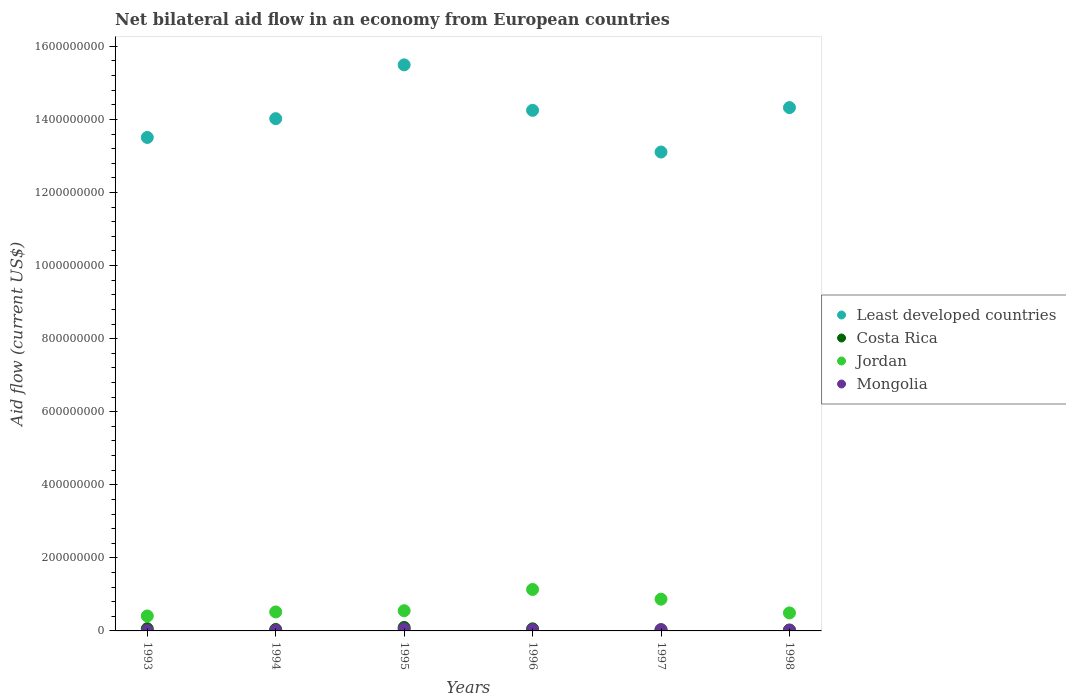How many different coloured dotlines are there?
Give a very brief answer. 4. Is the number of dotlines equal to the number of legend labels?
Give a very brief answer. Yes. What is the net bilateral aid flow in Costa Rica in 1998?
Provide a short and direct response. 2.54e+06. Across all years, what is the maximum net bilateral aid flow in Least developed countries?
Your response must be concise. 1.55e+09. Across all years, what is the minimum net bilateral aid flow in Least developed countries?
Give a very brief answer. 1.31e+09. What is the total net bilateral aid flow in Mongolia in the graph?
Your response must be concise. 1.52e+07. What is the difference between the net bilateral aid flow in Jordan in 1994 and that in 1998?
Provide a short and direct response. 2.73e+06. What is the difference between the net bilateral aid flow in Costa Rica in 1993 and the net bilateral aid flow in Least developed countries in 1994?
Your answer should be very brief. -1.40e+09. What is the average net bilateral aid flow in Mongolia per year?
Your answer should be compact. 2.54e+06. In the year 1994, what is the difference between the net bilateral aid flow in Least developed countries and net bilateral aid flow in Jordan?
Provide a succinct answer. 1.35e+09. What is the ratio of the net bilateral aid flow in Jordan in 1993 to that in 1998?
Ensure brevity in your answer.  0.83. Is the net bilateral aid flow in Jordan in 1993 less than that in 1996?
Your answer should be very brief. Yes. What is the difference between the highest and the second highest net bilateral aid flow in Mongolia?
Make the answer very short. 1.83e+06. What is the difference between the highest and the lowest net bilateral aid flow in Mongolia?
Your answer should be very brief. 4.03e+06. In how many years, is the net bilateral aid flow in Mongolia greater than the average net bilateral aid flow in Mongolia taken over all years?
Your response must be concise. 3. Is it the case that in every year, the sum of the net bilateral aid flow in Jordan and net bilateral aid flow in Mongolia  is greater than the net bilateral aid flow in Least developed countries?
Ensure brevity in your answer.  No. How many dotlines are there?
Provide a short and direct response. 4. How many years are there in the graph?
Your response must be concise. 6. Are the values on the major ticks of Y-axis written in scientific E-notation?
Offer a terse response. No. Does the graph contain grids?
Provide a succinct answer. No. Where does the legend appear in the graph?
Your response must be concise. Center right. What is the title of the graph?
Your response must be concise. Net bilateral aid flow in an economy from European countries. What is the label or title of the X-axis?
Offer a very short reply. Years. What is the label or title of the Y-axis?
Make the answer very short. Aid flow (current US$). What is the Aid flow (current US$) in Least developed countries in 1993?
Your answer should be very brief. 1.35e+09. What is the Aid flow (current US$) of Costa Rica in 1993?
Provide a short and direct response. 6.09e+06. What is the Aid flow (current US$) of Jordan in 1993?
Offer a terse response. 4.09e+07. What is the Aid flow (current US$) in Mongolia in 1993?
Your response must be concise. 9.60e+05. What is the Aid flow (current US$) of Least developed countries in 1994?
Keep it short and to the point. 1.40e+09. What is the Aid flow (current US$) of Costa Rica in 1994?
Offer a very short reply. 4.01e+06. What is the Aid flow (current US$) in Jordan in 1994?
Your answer should be compact. 5.20e+07. What is the Aid flow (current US$) of Mongolia in 1994?
Your answer should be compact. 1.42e+06. What is the Aid flow (current US$) in Least developed countries in 1995?
Offer a very short reply. 1.55e+09. What is the Aid flow (current US$) in Costa Rica in 1995?
Provide a succinct answer. 9.50e+06. What is the Aid flow (current US$) of Jordan in 1995?
Offer a terse response. 5.53e+07. What is the Aid flow (current US$) in Mongolia in 1995?
Keep it short and to the point. 4.99e+06. What is the Aid flow (current US$) in Least developed countries in 1996?
Give a very brief answer. 1.42e+09. What is the Aid flow (current US$) of Costa Rica in 1996?
Your answer should be compact. 5.70e+06. What is the Aid flow (current US$) of Jordan in 1996?
Offer a terse response. 1.13e+08. What is the Aid flow (current US$) in Mongolia in 1996?
Provide a short and direct response. 2.97e+06. What is the Aid flow (current US$) of Least developed countries in 1997?
Make the answer very short. 1.31e+09. What is the Aid flow (current US$) of Costa Rica in 1997?
Provide a short and direct response. 3.22e+06. What is the Aid flow (current US$) in Jordan in 1997?
Offer a very short reply. 8.69e+07. What is the Aid flow (current US$) of Mongolia in 1997?
Make the answer very short. 3.16e+06. What is the Aid flow (current US$) of Least developed countries in 1998?
Provide a succinct answer. 1.43e+09. What is the Aid flow (current US$) of Costa Rica in 1998?
Your answer should be very brief. 2.54e+06. What is the Aid flow (current US$) in Jordan in 1998?
Give a very brief answer. 4.93e+07. What is the Aid flow (current US$) of Mongolia in 1998?
Provide a succinct answer. 1.74e+06. Across all years, what is the maximum Aid flow (current US$) of Least developed countries?
Provide a succinct answer. 1.55e+09. Across all years, what is the maximum Aid flow (current US$) in Costa Rica?
Your response must be concise. 9.50e+06. Across all years, what is the maximum Aid flow (current US$) in Jordan?
Provide a succinct answer. 1.13e+08. Across all years, what is the maximum Aid flow (current US$) of Mongolia?
Your response must be concise. 4.99e+06. Across all years, what is the minimum Aid flow (current US$) in Least developed countries?
Your answer should be compact. 1.31e+09. Across all years, what is the minimum Aid flow (current US$) of Costa Rica?
Provide a short and direct response. 2.54e+06. Across all years, what is the minimum Aid flow (current US$) of Jordan?
Give a very brief answer. 4.09e+07. Across all years, what is the minimum Aid flow (current US$) of Mongolia?
Provide a short and direct response. 9.60e+05. What is the total Aid flow (current US$) of Least developed countries in the graph?
Your answer should be very brief. 8.47e+09. What is the total Aid flow (current US$) in Costa Rica in the graph?
Your response must be concise. 3.11e+07. What is the total Aid flow (current US$) of Jordan in the graph?
Offer a terse response. 3.98e+08. What is the total Aid flow (current US$) of Mongolia in the graph?
Ensure brevity in your answer.  1.52e+07. What is the difference between the Aid flow (current US$) in Least developed countries in 1993 and that in 1994?
Offer a terse response. -5.14e+07. What is the difference between the Aid flow (current US$) of Costa Rica in 1993 and that in 1994?
Give a very brief answer. 2.08e+06. What is the difference between the Aid flow (current US$) in Jordan in 1993 and that in 1994?
Your response must be concise. -1.11e+07. What is the difference between the Aid flow (current US$) in Mongolia in 1993 and that in 1994?
Provide a succinct answer. -4.60e+05. What is the difference between the Aid flow (current US$) of Least developed countries in 1993 and that in 1995?
Ensure brevity in your answer.  -1.99e+08. What is the difference between the Aid flow (current US$) of Costa Rica in 1993 and that in 1995?
Provide a short and direct response. -3.41e+06. What is the difference between the Aid flow (current US$) in Jordan in 1993 and that in 1995?
Your response must be concise. -1.44e+07. What is the difference between the Aid flow (current US$) of Mongolia in 1993 and that in 1995?
Your response must be concise. -4.03e+06. What is the difference between the Aid flow (current US$) in Least developed countries in 1993 and that in 1996?
Give a very brief answer. -7.42e+07. What is the difference between the Aid flow (current US$) of Jordan in 1993 and that in 1996?
Ensure brevity in your answer.  -7.25e+07. What is the difference between the Aid flow (current US$) of Mongolia in 1993 and that in 1996?
Provide a succinct answer. -2.01e+06. What is the difference between the Aid flow (current US$) of Least developed countries in 1993 and that in 1997?
Your answer should be very brief. 3.99e+07. What is the difference between the Aid flow (current US$) in Costa Rica in 1993 and that in 1997?
Provide a short and direct response. 2.87e+06. What is the difference between the Aid flow (current US$) of Jordan in 1993 and that in 1997?
Provide a succinct answer. -4.60e+07. What is the difference between the Aid flow (current US$) in Mongolia in 1993 and that in 1997?
Provide a succinct answer. -2.20e+06. What is the difference between the Aid flow (current US$) in Least developed countries in 1993 and that in 1998?
Ensure brevity in your answer.  -8.18e+07. What is the difference between the Aid flow (current US$) of Costa Rica in 1993 and that in 1998?
Your response must be concise. 3.55e+06. What is the difference between the Aid flow (current US$) in Jordan in 1993 and that in 1998?
Make the answer very short. -8.36e+06. What is the difference between the Aid flow (current US$) of Mongolia in 1993 and that in 1998?
Provide a short and direct response. -7.80e+05. What is the difference between the Aid flow (current US$) of Least developed countries in 1994 and that in 1995?
Offer a very short reply. -1.47e+08. What is the difference between the Aid flow (current US$) in Costa Rica in 1994 and that in 1995?
Provide a succinct answer. -5.49e+06. What is the difference between the Aid flow (current US$) of Jordan in 1994 and that in 1995?
Your answer should be very brief. -3.35e+06. What is the difference between the Aid flow (current US$) of Mongolia in 1994 and that in 1995?
Provide a short and direct response. -3.57e+06. What is the difference between the Aid flow (current US$) of Least developed countries in 1994 and that in 1996?
Offer a very short reply. -2.28e+07. What is the difference between the Aid flow (current US$) in Costa Rica in 1994 and that in 1996?
Your response must be concise. -1.69e+06. What is the difference between the Aid flow (current US$) of Jordan in 1994 and that in 1996?
Your answer should be very brief. -6.14e+07. What is the difference between the Aid flow (current US$) in Mongolia in 1994 and that in 1996?
Provide a short and direct response. -1.55e+06. What is the difference between the Aid flow (current US$) in Least developed countries in 1994 and that in 1997?
Your answer should be compact. 9.13e+07. What is the difference between the Aid flow (current US$) in Costa Rica in 1994 and that in 1997?
Your response must be concise. 7.90e+05. What is the difference between the Aid flow (current US$) of Jordan in 1994 and that in 1997?
Make the answer very short. -3.50e+07. What is the difference between the Aid flow (current US$) in Mongolia in 1994 and that in 1997?
Provide a succinct answer. -1.74e+06. What is the difference between the Aid flow (current US$) in Least developed countries in 1994 and that in 1998?
Your answer should be compact. -3.03e+07. What is the difference between the Aid flow (current US$) of Costa Rica in 1994 and that in 1998?
Provide a short and direct response. 1.47e+06. What is the difference between the Aid flow (current US$) in Jordan in 1994 and that in 1998?
Ensure brevity in your answer.  2.73e+06. What is the difference between the Aid flow (current US$) of Mongolia in 1994 and that in 1998?
Make the answer very short. -3.20e+05. What is the difference between the Aid flow (current US$) in Least developed countries in 1995 and that in 1996?
Your answer should be very brief. 1.24e+08. What is the difference between the Aid flow (current US$) of Costa Rica in 1995 and that in 1996?
Offer a terse response. 3.80e+06. What is the difference between the Aid flow (current US$) of Jordan in 1995 and that in 1996?
Ensure brevity in your answer.  -5.81e+07. What is the difference between the Aid flow (current US$) in Mongolia in 1995 and that in 1996?
Offer a very short reply. 2.02e+06. What is the difference between the Aid flow (current US$) of Least developed countries in 1995 and that in 1997?
Keep it short and to the point. 2.39e+08. What is the difference between the Aid flow (current US$) of Costa Rica in 1995 and that in 1997?
Ensure brevity in your answer.  6.28e+06. What is the difference between the Aid flow (current US$) of Jordan in 1995 and that in 1997?
Keep it short and to the point. -3.16e+07. What is the difference between the Aid flow (current US$) in Mongolia in 1995 and that in 1997?
Ensure brevity in your answer.  1.83e+06. What is the difference between the Aid flow (current US$) in Least developed countries in 1995 and that in 1998?
Your answer should be compact. 1.17e+08. What is the difference between the Aid flow (current US$) of Costa Rica in 1995 and that in 1998?
Provide a short and direct response. 6.96e+06. What is the difference between the Aid flow (current US$) of Jordan in 1995 and that in 1998?
Make the answer very short. 6.08e+06. What is the difference between the Aid flow (current US$) of Mongolia in 1995 and that in 1998?
Your response must be concise. 3.25e+06. What is the difference between the Aid flow (current US$) in Least developed countries in 1996 and that in 1997?
Your response must be concise. 1.14e+08. What is the difference between the Aid flow (current US$) of Costa Rica in 1996 and that in 1997?
Offer a very short reply. 2.48e+06. What is the difference between the Aid flow (current US$) in Jordan in 1996 and that in 1997?
Make the answer very short. 2.65e+07. What is the difference between the Aid flow (current US$) in Least developed countries in 1996 and that in 1998?
Give a very brief answer. -7.51e+06. What is the difference between the Aid flow (current US$) in Costa Rica in 1996 and that in 1998?
Offer a terse response. 3.16e+06. What is the difference between the Aid flow (current US$) in Jordan in 1996 and that in 1998?
Offer a terse response. 6.42e+07. What is the difference between the Aid flow (current US$) of Mongolia in 1996 and that in 1998?
Provide a succinct answer. 1.23e+06. What is the difference between the Aid flow (current US$) of Least developed countries in 1997 and that in 1998?
Ensure brevity in your answer.  -1.22e+08. What is the difference between the Aid flow (current US$) in Costa Rica in 1997 and that in 1998?
Make the answer very short. 6.80e+05. What is the difference between the Aid flow (current US$) of Jordan in 1997 and that in 1998?
Provide a short and direct response. 3.77e+07. What is the difference between the Aid flow (current US$) in Mongolia in 1997 and that in 1998?
Provide a succinct answer. 1.42e+06. What is the difference between the Aid flow (current US$) of Least developed countries in 1993 and the Aid flow (current US$) of Costa Rica in 1994?
Make the answer very short. 1.35e+09. What is the difference between the Aid flow (current US$) in Least developed countries in 1993 and the Aid flow (current US$) in Jordan in 1994?
Ensure brevity in your answer.  1.30e+09. What is the difference between the Aid flow (current US$) of Least developed countries in 1993 and the Aid flow (current US$) of Mongolia in 1994?
Provide a succinct answer. 1.35e+09. What is the difference between the Aid flow (current US$) of Costa Rica in 1993 and the Aid flow (current US$) of Jordan in 1994?
Your answer should be very brief. -4.59e+07. What is the difference between the Aid flow (current US$) of Costa Rica in 1993 and the Aid flow (current US$) of Mongolia in 1994?
Offer a very short reply. 4.67e+06. What is the difference between the Aid flow (current US$) of Jordan in 1993 and the Aid flow (current US$) of Mongolia in 1994?
Ensure brevity in your answer.  3.95e+07. What is the difference between the Aid flow (current US$) of Least developed countries in 1993 and the Aid flow (current US$) of Costa Rica in 1995?
Provide a succinct answer. 1.34e+09. What is the difference between the Aid flow (current US$) in Least developed countries in 1993 and the Aid flow (current US$) in Jordan in 1995?
Your response must be concise. 1.30e+09. What is the difference between the Aid flow (current US$) of Least developed countries in 1993 and the Aid flow (current US$) of Mongolia in 1995?
Your response must be concise. 1.35e+09. What is the difference between the Aid flow (current US$) in Costa Rica in 1993 and the Aid flow (current US$) in Jordan in 1995?
Offer a very short reply. -4.92e+07. What is the difference between the Aid flow (current US$) in Costa Rica in 1993 and the Aid flow (current US$) in Mongolia in 1995?
Provide a short and direct response. 1.10e+06. What is the difference between the Aid flow (current US$) of Jordan in 1993 and the Aid flow (current US$) of Mongolia in 1995?
Keep it short and to the point. 3.59e+07. What is the difference between the Aid flow (current US$) in Least developed countries in 1993 and the Aid flow (current US$) in Costa Rica in 1996?
Make the answer very short. 1.34e+09. What is the difference between the Aid flow (current US$) in Least developed countries in 1993 and the Aid flow (current US$) in Jordan in 1996?
Provide a succinct answer. 1.24e+09. What is the difference between the Aid flow (current US$) of Least developed countries in 1993 and the Aid flow (current US$) of Mongolia in 1996?
Keep it short and to the point. 1.35e+09. What is the difference between the Aid flow (current US$) of Costa Rica in 1993 and the Aid flow (current US$) of Jordan in 1996?
Your response must be concise. -1.07e+08. What is the difference between the Aid flow (current US$) of Costa Rica in 1993 and the Aid flow (current US$) of Mongolia in 1996?
Keep it short and to the point. 3.12e+06. What is the difference between the Aid flow (current US$) in Jordan in 1993 and the Aid flow (current US$) in Mongolia in 1996?
Ensure brevity in your answer.  3.79e+07. What is the difference between the Aid flow (current US$) in Least developed countries in 1993 and the Aid flow (current US$) in Costa Rica in 1997?
Your response must be concise. 1.35e+09. What is the difference between the Aid flow (current US$) in Least developed countries in 1993 and the Aid flow (current US$) in Jordan in 1997?
Your answer should be very brief. 1.26e+09. What is the difference between the Aid flow (current US$) of Least developed countries in 1993 and the Aid flow (current US$) of Mongolia in 1997?
Make the answer very short. 1.35e+09. What is the difference between the Aid flow (current US$) of Costa Rica in 1993 and the Aid flow (current US$) of Jordan in 1997?
Your response must be concise. -8.08e+07. What is the difference between the Aid flow (current US$) in Costa Rica in 1993 and the Aid flow (current US$) in Mongolia in 1997?
Offer a very short reply. 2.93e+06. What is the difference between the Aid flow (current US$) of Jordan in 1993 and the Aid flow (current US$) of Mongolia in 1997?
Make the answer very short. 3.77e+07. What is the difference between the Aid flow (current US$) of Least developed countries in 1993 and the Aid flow (current US$) of Costa Rica in 1998?
Offer a very short reply. 1.35e+09. What is the difference between the Aid flow (current US$) in Least developed countries in 1993 and the Aid flow (current US$) in Jordan in 1998?
Provide a short and direct response. 1.30e+09. What is the difference between the Aid flow (current US$) of Least developed countries in 1993 and the Aid flow (current US$) of Mongolia in 1998?
Provide a short and direct response. 1.35e+09. What is the difference between the Aid flow (current US$) in Costa Rica in 1993 and the Aid flow (current US$) in Jordan in 1998?
Provide a short and direct response. -4.32e+07. What is the difference between the Aid flow (current US$) in Costa Rica in 1993 and the Aid flow (current US$) in Mongolia in 1998?
Ensure brevity in your answer.  4.35e+06. What is the difference between the Aid flow (current US$) in Jordan in 1993 and the Aid flow (current US$) in Mongolia in 1998?
Offer a terse response. 3.92e+07. What is the difference between the Aid flow (current US$) of Least developed countries in 1994 and the Aid flow (current US$) of Costa Rica in 1995?
Make the answer very short. 1.39e+09. What is the difference between the Aid flow (current US$) in Least developed countries in 1994 and the Aid flow (current US$) in Jordan in 1995?
Your answer should be compact. 1.35e+09. What is the difference between the Aid flow (current US$) of Least developed countries in 1994 and the Aid flow (current US$) of Mongolia in 1995?
Your answer should be very brief. 1.40e+09. What is the difference between the Aid flow (current US$) of Costa Rica in 1994 and the Aid flow (current US$) of Jordan in 1995?
Provide a short and direct response. -5.13e+07. What is the difference between the Aid flow (current US$) in Costa Rica in 1994 and the Aid flow (current US$) in Mongolia in 1995?
Offer a terse response. -9.80e+05. What is the difference between the Aid flow (current US$) of Jordan in 1994 and the Aid flow (current US$) of Mongolia in 1995?
Offer a terse response. 4.70e+07. What is the difference between the Aid flow (current US$) of Least developed countries in 1994 and the Aid flow (current US$) of Costa Rica in 1996?
Ensure brevity in your answer.  1.40e+09. What is the difference between the Aid flow (current US$) in Least developed countries in 1994 and the Aid flow (current US$) in Jordan in 1996?
Ensure brevity in your answer.  1.29e+09. What is the difference between the Aid flow (current US$) of Least developed countries in 1994 and the Aid flow (current US$) of Mongolia in 1996?
Provide a succinct answer. 1.40e+09. What is the difference between the Aid flow (current US$) in Costa Rica in 1994 and the Aid flow (current US$) in Jordan in 1996?
Your answer should be very brief. -1.09e+08. What is the difference between the Aid flow (current US$) of Costa Rica in 1994 and the Aid flow (current US$) of Mongolia in 1996?
Offer a very short reply. 1.04e+06. What is the difference between the Aid flow (current US$) in Jordan in 1994 and the Aid flow (current US$) in Mongolia in 1996?
Provide a short and direct response. 4.90e+07. What is the difference between the Aid flow (current US$) of Least developed countries in 1994 and the Aid flow (current US$) of Costa Rica in 1997?
Your response must be concise. 1.40e+09. What is the difference between the Aid flow (current US$) in Least developed countries in 1994 and the Aid flow (current US$) in Jordan in 1997?
Ensure brevity in your answer.  1.32e+09. What is the difference between the Aid flow (current US$) in Least developed countries in 1994 and the Aid flow (current US$) in Mongolia in 1997?
Provide a short and direct response. 1.40e+09. What is the difference between the Aid flow (current US$) of Costa Rica in 1994 and the Aid flow (current US$) of Jordan in 1997?
Your answer should be very brief. -8.29e+07. What is the difference between the Aid flow (current US$) of Costa Rica in 1994 and the Aid flow (current US$) of Mongolia in 1997?
Ensure brevity in your answer.  8.50e+05. What is the difference between the Aid flow (current US$) in Jordan in 1994 and the Aid flow (current US$) in Mongolia in 1997?
Provide a short and direct response. 4.88e+07. What is the difference between the Aid flow (current US$) of Least developed countries in 1994 and the Aid flow (current US$) of Costa Rica in 1998?
Your answer should be compact. 1.40e+09. What is the difference between the Aid flow (current US$) in Least developed countries in 1994 and the Aid flow (current US$) in Jordan in 1998?
Provide a succinct answer. 1.35e+09. What is the difference between the Aid flow (current US$) of Least developed countries in 1994 and the Aid flow (current US$) of Mongolia in 1998?
Ensure brevity in your answer.  1.40e+09. What is the difference between the Aid flow (current US$) of Costa Rica in 1994 and the Aid flow (current US$) of Jordan in 1998?
Provide a succinct answer. -4.52e+07. What is the difference between the Aid flow (current US$) in Costa Rica in 1994 and the Aid flow (current US$) in Mongolia in 1998?
Ensure brevity in your answer.  2.27e+06. What is the difference between the Aid flow (current US$) of Jordan in 1994 and the Aid flow (current US$) of Mongolia in 1998?
Give a very brief answer. 5.02e+07. What is the difference between the Aid flow (current US$) of Least developed countries in 1995 and the Aid flow (current US$) of Costa Rica in 1996?
Provide a succinct answer. 1.54e+09. What is the difference between the Aid flow (current US$) in Least developed countries in 1995 and the Aid flow (current US$) in Jordan in 1996?
Provide a short and direct response. 1.44e+09. What is the difference between the Aid flow (current US$) in Least developed countries in 1995 and the Aid flow (current US$) in Mongolia in 1996?
Offer a very short reply. 1.55e+09. What is the difference between the Aid flow (current US$) in Costa Rica in 1995 and the Aid flow (current US$) in Jordan in 1996?
Offer a very short reply. -1.04e+08. What is the difference between the Aid flow (current US$) in Costa Rica in 1995 and the Aid flow (current US$) in Mongolia in 1996?
Provide a succinct answer. 6.53e+06. What is the difference between the Aid flow (current US$) in Jordan in 1995 and the Aid flow (current US$) in Mongolia in 1996?
Offer a very short reply. 5.24e+07. What is the difference between the Aid flow (current US$) of Least developed countries in 1995 and the Aid flow (current US$) of Costa Rica in 1997?
Offer a terse response. 1.55e+09. What is the difference between the Aid flow (current US$) in Least developed countries in 1995 and the Aid flow (current US$) in Jordan in 1997?
Your answer should be compact. 1.46e+09. What is the difference between the Aid flow (current US$) of Least developed countries in 1995 and the Aid flow (current US$) of Mongolia in 1997?
Keep it short and to the point. 1.55e+09. What is the difference between the Aid flow (current US$) of Costa Rica in 1995 and the Aid flow (current US$) of Jordan in 1997?
Keep it short and to the point. -7.74e+07. What is the difference between the Aid flow (current US$) in Costa Rica in 1995 and the Aid flow (current US$) in Mongolia in 1997?
Your answer should be very brief. 6.34e+06. What is the difference between the Aid flow (current US$) of Jordan in 1995 and the Aid flow (current US$) of Mongolia in 1997?
Your answer should be very brief. 5.22e+07. What is the difference between the Aid flow (current US$) in Least developed countries in 1995 and the Aid flow (current US$) in Costa Rica in 1998?
Offer a very short reply. 1.55e+09. What is the difference between the Aid flow (current US$) in Least developed countries in 1995 and the Aid flow (current US$) in Jordan in 1998?
Provide a succinct answer. 1.50e+09. What is the difference between the Aid flow (current US$) in Least developed countries in 1995 and the Aid flow (current US$) in Mongolia in 1998?
Offer a terse response. 1.55e+09. What is the difference between the Aid flow (current US$) in Costa Rica in 1995 and the Aid flow (current US$) in Jordan in 1998?
Keep it short and to the point. -3.98e+07. What is the difference between the Aid flow (current US$) in Costa Rica in 1995 and the Aid flow (current US$) in Mongolia in 1998?
Your response must be concise. 7.76e+06. What is the difference between the Aid flow (current US$) in Jordan in 1995 and the Aid flow (current US$) in Mongolia in 1998?
Your response must be concise. 5.36e+07. What is the difference between the Aid flow (current US$) in Least developed countries in 1996 and the Aid flow (current US$) in Costa Rica in 1997?
Offer a very short reply. 1.42e+09. What is the difference between the Aid flow (current US$) in Least developed countries in 1996 and the Aid flow (current US$) in Jordan in 1997?
Ensure brevity in your answer.  1.34e+09. What is the difference between the Aid flow (current US$) of Least developed countries in 1996 and the Aid flow (current US$) of Mongolia in 1997?
Ensure brevity in your answer.  1.42e+09. What is the difference between the Aid flow (current US$) of Costa Rica in 1996 and the Aid flow (current US$) of Jordan in 1997?
Offer a terse response. -8.12e+07. What is the difference between the Aid flow (current US$) of Costa Rica in 1996 and the Aid flow (current US$) of Mongolia in 1997?
Your answer should be very brief. 2.54e+06. What is the difference between the Aid flow (current US$) in Jordan in 1996 and the Aid flow (current US$) in Mongolia in 1997?
Your answer should be compact. 1.10e+08. What is the difference between the Aid flow (current US$) in Least developed countries in 1996 and the Aid flow (current US$) in Costa Rica in 1998?
Offer a very short reply. 1.42e+09. What is the difference between the Aid flow (current US$) in Least developed countries in 1996 and the Aid flow (current US$) in Jordan in 1998?
Offer a very short reply. 1.38e+09. What is the difference between the Aid flow (current US$) in Least developed countries in 1996 and the Aid flow (current US$) in Mongolia in 1998?
Provide a succinct answer. 1.42e+09. What is the difference between the Aid flow (current US$) of Costa Rica in 1996 and the Aid flow (current US$) of Jordan in 1998?
Provide a short and direct response. -4.36e+07. What is the difference between the Aid flow (current US$) in Costa Rica in 1996 and the Aid flow (current US$) in Mongolia in 1998?
Offer a very short reply. 3.96e+06. What is the difference between the Aid flow (current US$) in Jordan in 1996 and the Aid flow (current US$) in Mongolia in 1998?
Your response must be concise. 1.12e+08. What is the difference between the Aid flow (current US$) of Least developed countries in 1997 and the Aid flow (current US$) of Costa Rica in 1998?
Your answer should be compact. 1.31e+09. What is the difference between the Aid flow (current US$) in Least developed countries in 1997 and the Aid flow (current US$) in Jordan in 1998?
Offer a very short reply. 1.26e+09. What is the difference between the Aid flow (current US$) in Least developed countries in 1997 and the Aid flow (current US$) in Mongolia in 1998?
Make the answer very short. 1.31e+09. What is the difference between the Aid flow (current US$) in Costa Rica in 1997 and the Aid flow (current US$) in Jordan in 1998?
Your answer should be very brief. -4.60e+07. What is the difference between the Aid flow (current US$) of Costa Rica in 1997 and the Aid flow (current US$) of Mongolia in 1998?
Offer a very short reply. 1.48e+06. What is the difference between the Aid flow (current US$) in Jordan in 1997 and the Aid flow (current US$) in Mongolia in 1998?
Offer a very short reply. 8.52e+07. What is the average Aid flow (current US$) of Least developed countries per year?
Your response must be concise. 1.41e+09. What is the average Aid flow (current US$) in Costa Rica per year?
Offer a very short reply. 5.18e+06. What is the average Aid flow (current US$) of Jordan per year?
Your answer should be compact. 6.63e+07. What is the average Aid flow (current US$) in Mongolia per year?
Give a very brief answer. 2.54e+06. In the year 1993, what is the difference between the Aid flow (current US$) in Least developed countries and Aid flow (current US$) in Costa Rica?
Provide a short and direct response. 1.34e+09. In the year 1993, what is the difference between the Aid flow (current US$) of Least developed countries and Aid flow (current US$) of Jordan?
Your answer should be very brief. 1.31e+09. In the year 1993, what is the difference between the Aid flow (current US$) in Least developed countries and Aid flow (current US$) in Mongolia?
Your answer should be very brief. 1.35e+09. In the year 1993, what is the difference between the Aid flow (current US$) of Costa Rica and Aid flow (current US$) of Jordan?
Your response must be concise. -3.48e+07. In the year 1993, what is the difference between the Aid flow (current US$) of Costa Rica and Aid flow (current US$) of Mongolia?
Offer a terse response. 5.13e+06. In the year 1993, what is the difference between the Aid flow (current US$) of Jordan and Aid flow (current US$) of Mongolia?
Give a very brief answer. 3.99e+07. In the year 1994, what is the difference between the Aid flow (current US$) of Least developed countries and Aid flow (current US$) of Costa Rica?
Make the answer very short. 1.40e+09. In the year 1994, what is the difference between the Aid flow (current US$) in Least developed countries and Aid flow (current US$) in Jordan?
Your response must be concise. 1.35e+09. In the year 1994, what is the difference between the Aid flow (current US$) in Least developed countries and Aid flow (current US$) in Mongolia?
Provide a short and direct response. 1.40e+09. In the year 1994, what is the difference between the Aid flow (current US$) in Costa Rica and Aid flow (current US$) in Jordan?
Your answer should be very brief. -4.80e+07. In the year 1994, what is the difference between the Aid flow (current US$) in Costa Rica and Aid flow (current US$) in Mongolia?
Make the answer very short. 2.59e+06. In the year 1994, what is the difference between the Aid flow (current US$) in Jordan and Aid flow (current US$) in Mongolia?
Ensure brevity in your answer.  5.06e+07. In the year 1995, what is the difference between the Aid flow (current US$) in Least developed countries and Aid flow (current US$) in Costa Rica?
Provide a succinct answer. 1.54e+09. In the year 1995, what is the difference between the Aid flow (current US$) in Least developed countries and Aid flow (current US$) in Jordan?
Ensure brevity in your answer.  1.49e+09. In the year 1995, what is the difference between the Aid flow (current US$) of Least developed countries and Aid flow (current US$) of Mongolia?
Keep it short and to the point. 1.54e+09. In the year 1995, what is the difference between the Aid flow (current US$) of Costa Rica and Aid flow (current US$) of Jordan?
Ensure brevity in your answer.  -4.58e+07. In the year 1995, what is the difference between the Aid flow (current US$) of Costa Rica and Aid flow (current US$) of Mongolia?
Give a very brief answer. 4.51e+06. In the year 1995, what is the difference between the Aid flow (current US$) in Jordan and Aid flow (current US$) in Mongolia?
Provide a succinct answer. 5.04e+07. In the year 1996, what is the difference between the Aid flow (current US$) of Least developed countries and Aid flow (current US$) of Costa Rica?
Keep it short and to the point. 1.42e+09. In the year 1996, what is the difference between the Aid flow (current US$) in Least developed countries and Aid flow (current US$) in Jordan?
Your response must be concise. 1.31e+09. In the year 1996, what is the difference between the Aid flow (current US$) in Least developed countries and Aid flow (current US$) in Mongolia?
Offer a terse response. 1.42e+09. In the year 1996, what is the difference between the Aid flow (current US$) in Costa Rica and Aid flow (current US$) in Jordan?
Your response must be concise. -1.08e+08. In the year 1996, what is the difference between the Aid flow (current US$) in Costa Rica and Aid flow (current US$) in Mongolia?
Give a very brief answer. 2.73e+06. In the year 1996, what is the difference between the Aid flow (current US$) in Jordan and Aid flow (current US$) in Mongolia?
Your answer should be very brief. 1.10e+08. In the year 1997, what is the difference between the Aid flow (current US$) of Least developed countries and Aid flow (current US$) of Costa Rica?
Provide a short and direct response. 1.31e+09. In the year 1997, what is the difference between the Aid flow (current US$) in Least developed countries and Aid flow (current US$) in Jordan?
Offer a very short reply. 1.22e+09. In the year 1997, what is the difference between the Aid flow (current US$) in Least developed countries and Aid flow (current US$) in Mongolia?
Your answer should be very brief. 1.31e+09. In the year 1997, what is the difference between the Aid flow (current US$) in Costa Rica and Aid flow (current US$) in Jordan?
Offer a very short reply. -8.37e+07. In the year 1997, what is the difference between the Aid flow (current US$) of Jordan and Aid flow (current US$) of Mongolia?
Offer a terse response. 8.38e+07. In the year 1998, what is the difference between the Aid flow (current US$) in Least developed countries and Aid flow (current US$) in Costa Rica?
Provide a short and direct response. 1.43e+09. In the year 1998, what is the difference between the Aid flow (current US$) of Least developed countries and Aid flow (current US$) of Jordan?
Your answer should be very brief. 1.38e+09. In the year 1998, what is the difference between the Aid flow (current US$) of Least developed countries and Aid flow (current US$) of Mongolia?
Provide a short and direct response. 1.43e+09. In the year 1998, what is the difference between the Aid flow (current US$) in Costa Rica and Aid flow (current US$) in Jordan?
Ensure brevity in your answer.  -4.67e+07. In the year 1998, what is the difference between the Aid flow (current US$) in Jordan and Aid flow (current US$) in Mongolia?
Your answer should be very brief. 4.75e+07. What is the ratio of the Aid flow (current US$) in Least developed countries in 1993 to that in 1994?
Your answer should be compact. 0.96. What is the ratio of the Aid flow (current US$) of Costa Rica in 1993 to that in 1994?
Provide a short and direct response. 1.52. What is the ratio of the Aid flow (current US$) of Jordan in 1993 to that in 1994?
Provide a short and direct response. 0.79. What is the ratio of the Aid flow (current US$) of Mongolia in 1993 to that in 1994?
Your answer should be compact. 0.68. What is the ratio of the Aid flow (current US$) in Least developed countries in 1993 to that in 1995?
Ensure brevity in your answer.  0.87. What is the ratio of the Aid flow (current US$) of Costa Rica in 1993 to that in 1995?
Your response must be concise. 0.64. What is the ratio of the Aid flow (current US$) of Jordan in 1993 to that in 1995?
Keep it short and to the point. 0.74. What is the ratio of the Aid flow (current US$) in Mongolia in 1993 to that in 1995?
Offer a terse response. 0.19. What is the ratio of the Aid flow (current US$) of Least developed countries in 1993 to that in 1996?
Offer a very short reply. 0.95. What is the ratio of the Aid flow (current US$) in Costa Rica in 1993 to that in 1996?
Your answer should be compact. 1.07. What is the ratio of the Aid flow (current US$) of Jordan in 1993 to that in 1996?
Provide a succinct answer. 0.36. What is the ratio of the Aid flow (current US$) in Mongolia in 1993 to that in 1996?
Make the answer very short. 0.32. What is the ratio of the Aid flow (current US$) of Least developed countries in 1993 to that in 1997?
Provide a succinct answer. 1.03. What is the ratio of the Aid flow (current US$) in Costa Rica in 1993 to that in 1997?
Give a very brief answer. 1.89. What is the ratio of the Aid flow (current US$) of Jordan in 1993 to that in 1997?
Your answer should be very brief. 0.47. What is the ratio of the Aid flow (current US$) of Mongolia in 1993 to that in 1997?
Keep it short and to the point. 0.3. What is the ratio of the Aid flow (current US$) of Least developed countries in 1993 to that in 1998?
Ensure brevity in your answer.  0.94. What is the ratio of the Aid flow (current US$) of Costa Rica in 1993 to that in 1998?
Your answer should be compact. 2.4. What is the ratio of the Aid flow (current US$) of Jordan in 1993 to that in 1998?
Ensure brevity in your answer.  0.83. What is the ratio of the Aid flow (current US$) of Mongolia in 1993 to that in 1998?
Keep it short and to the point. 0.55. What is the ratio of the Aid flow (current US$) of Least developed countries in 1994 to that in 1995?
Provide a succinct answer. 0.91. What is the ratio of the Aid flow (current US$) in Costa Rica in 1994 to that in 1995?
Make the answer very short. 0.42. What is the ratio of the Aid flow (current US$) of Jordan in 1994 to that in 1995?
Ensure brevity in your answer.  0.94. What is the ratio of the Aid flow (current US$) of Mongolia in 1994 to that in 1995?
Offer a very short reply. 0.28. What is the ratio of the Aid flow (current US$) in Costa Rica in 1994 to that in 1996?
Provide a short and direct response. 0.7. What is the ratio of the Aid flow (current US$) of Jordan in 1994 to that in 1996?
Your response must be concise. 0.46. What is the ratio of the Aid flow (current US$) in Mongolia in 1994 to that in 1996?
Provide a short and direct response. 0.48. What is the ratio of the Aid flow (current US$) in Least developed countries in 1994 to that in 1997?
Provide a succinct answer. 1.07. What is the ratio of the Aid flow (current US$) of Costa Rica in 1994 to that in 1997?
Ensure brevity in your answer.  1.25. What is the ratio of the Aid flow (current US$) of Jordan in 1994 to that in 1997?
Offer a terse response. 0.6. What is the ratio of the Aid flow (current US$) in Mongolia in 1994 to that in 1997?
Offer a terse response. 0.45. What is the ratio of the Aid flow (current US$) of Least developed countries in 1994 to that in 1998?
Your answer should be compact. 0.98. What is the ratio of the Aid flow (current US$) of Costa Rica in 1994 to that in 1998?
Provide a succinct answer. 1.58. What is the ratio of the Aid flow (current US$) in Jordan in 1994 to that in 1998?
Your answer should be compact. 1.06. What is the ratio of the Aid flow (current US$) in Mongolia in 1994 to that in 1998?
Your answer should be very brief. 0.82. What is the ratio of the Aid flow (current US$) of Least developed countries in 1995 to that in 1996?
Ensure brevity in your answer.  1.09. What is the ratio of the Aid flow (current US$) in Costa Rica in 1995 to that in 1996?
Offer a terse response. 1.67. What is the ratio of the Aid flow (current US$) in Jordan in 1995 to that in 1996?
Provide a short and direct response. 0.49. What is the ratio of the Aid flow (current US$) in Mongolia in 1995 to that in 1996?
Keep it short and to the point. 1.68. What is the ratio of the Aid flow (current US$) in Least developed countries in 1995 to that in 1997?
Make the answer very short. 1.18. What is the ratio of the Aid flow (current US$) of Costa Rica in 1995 to that in 1997?
Offer a very short reply. 2.95. What is the ratio of the Aid flow (current US$) in Jordan in 1995 to that in 1997?
Offer a very short reply. 0.64. What is the ratio of the Aid flow (current US$) of Mongolia in 1995 to that in 1997?
Your response must be concise. 1.58. What is the ratio of the Aid flow (current US$) in Least developed countries in 1995 to that in 1998?
Provide a short and direct response. 1.08. What is the ratio of the Aid flow (current US$) of Costa Rica in 1995 to that in 1998?
Make the answer very short. 3.74. What is the ratio of the Aid flow (current US$) in Jordan in 1995 to that in 1998?
Your response must be concise. 1.12. What is the ratio of the Aid flow (current US$) of Mongolia in 1995 to that in 1998?
Make the answer very short. 2.87. What is the ratio of the Aid flow (current US$) of Least developed countries in 1996 to that in 1997?
Keep it short and to the point. 1.09. What is the ratio of the Aid flow (current US$) in Costa Rica in 1996 to that in 1997?
Keep it short and to the point. 1.77. What is the ratio of the Aid flow (current US$) in Jordan in 1996 to that in 1997?
Your answer should be very brief. 1.3. What is the ratio of the Aid flow (current US$) of Mongolia in 1996 to that in 1997?
Give a very brief answer. 0.94. What is the ratio of the Aid flow (current US$) in Costa Rica in 1996 to that in 1998?
Provide a short and direct response. 2.24. What is the ratio of the Aid flow (current US$) of Jordan in 1996 to that in 1998?
Provide a short and direct response. 2.3. What is the ratio of the Aid flow (current US$) in Mongolia in 1996 to that in 1998?
Offer a very short reply. 1.71. What is the ratio of the Aid flow (current US$) of Least developed countries in 1997 to that in 1998?
Provide a short and direct response. 0.92. What is the ratio of the Aid flow (current US$) in Costa Rica in 1997 to that in 1998?
Provide a short and direct response. 1.27. What is the ratio of the Aid flow (current US$) in Jordan in 1997 to that in 1998?
Your answer should be very brief. 1.76. What is the ratio of the Aid flow (current US$) in Mongolia in 1997 to that in 1998?
Make the answer very short. 1.82. What is the difference between the highest and the second highest Aid flow (current US$) of Least developed countries?
Provide a succinct answer. 1.17e+08. What is the difference between the highest and the second highest Aid flow (current US$) in Costa Rica?
Your response must be concise. 3.41e+06. What is the difference between the highest and the second highest Aid flow (current US$) in Jordan?
Offer a terse response. 2.65e+07. What is the difference between the highest and the second highest Aid flow (current US$) of Mongolia?
Provide a succinct answer. 1.83e+06. What is the difference between the highest and the lowest Aid flow (current US$) of Least developed countries?
Your answer should be compact. 2.39e+08. What is the difference between the highest and the lowest Aid flow (current US$) of Costa Rica?
Provide a short and direct response. 6.96e+06. What is the difference between the highest and the lowest Aid flow (current US$) of Jordan?
Give a very brief answer. 7.25e+07. What is the difference between the highest and the lowest Aid flow (current US$) of Mongolia?
Your answer should be compact. 4.03e+06. 